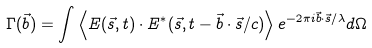Convert formula to latex. <formula><loc_0><loc_0><loc_500><loc_500>\Gamma ( \vec { b } ) = \int \left \langle E ( \vec { s } , t ) \cdot E ^ { * } ( \vec { s } , t - { \vec { b } \cdot \vec { s } } / { c } ) \right \rangle e ^ { { - 2 \pi i { \vec { b } \cdot \vec { s } } / \lambda } } d \Omega</formula> 